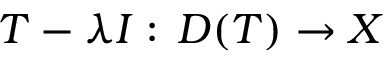<formula> <loc_0><loc_0><loc_500><loc_500>T - \lambda I \colon \, D ( T ) \to X</formula> 